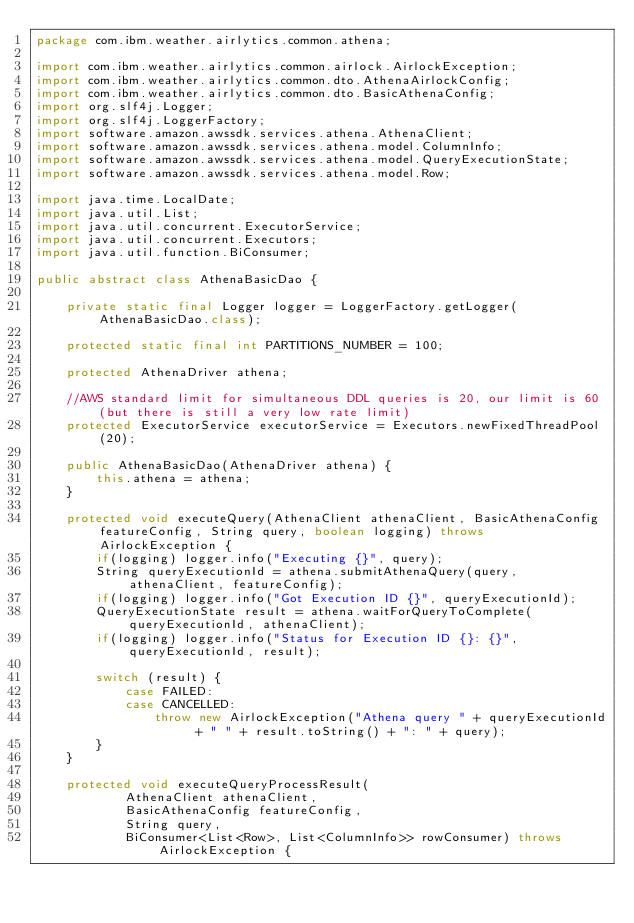<code> <loc_0><loc_0><loc_500><loc_500><_Java_>package com.ibm.weather.airlytics.common.athena;

import com.ibm.weather.airlytics.common.airlock.AirlockException;
import com.ibm.weather.airlytics.common.dto.AthenaAirlockConfig;
import com.ibm.weather.airlytics.common.dto.BasicAthenaConfig;
import org.slf4j.Logger;
import org.slf4j.LoggerFactory;
import software.amazon.awssdk.services.athena.AthenaClient;
import software.amazon.awssdk.services.athena.model.ColumnInfo;
import software.amazon.awssdk.services.athena.model.QueryExecutionState;
import software.amazon.awssdk.services.athena.model.Row;

import java.time.LocalDate;
import java.util.List;
import java.util.concurrent.ExecutorService;
import java.util.concurrent.Executors;
import java.util.function.BiConsumer;

public abstract class AthenaBasicDao {

    private static final Logger logger = LoggerFactory.getLogger(AthenaBasicDao.class);

    protected static final int PARTITIONS_NUMBER = 100;

    protected AthenaDriver athena;

    //AWS standard limit for simultaneous DDL queries is 20, our limit is 60 (but there is still a very low rate limit)
    protected ExecutorService executorService = Executors.newFixedThreadPool(20);

    public AthenaBasicDao(AthenaDriver athena) {
        this.athena = athena;
    }

    protected void executeQuery(AthenaClient athenaClient, BasicAthenaConfig featureConfig, String query, boolean logging) throws AirlockException {
        if(logging) logger.info("Executing {}", query);
        String queryExecutionId = athena.submitAthenaQuery(query, athenaClient, featureConfig);
        if(logging) logger.info("Got Execution ID {}", queryExecutionId);
        QueryExecutionState result = athena.waitForQueryToComplete(queryExecutionId, athenaClient);
        if(logging) logger.info("Status for Execution ID {}: {}", queryExecutionId, result);

        switch (result) {
            case FAILED:
            case CANCELLED:
                throw new AirlockException("Athena query " + queryExecutionId + " " + result.toString() + ": " + query);
        }
    }

    protected void executeQueryProcessResult(
            AthenaClient athenaClient,
            BasicAthenaConfig featureConfig,
            String query,
            BiConsumer<List<Row>, List<ColumnInfo>> rowConsumer) throws AirlockException {</code> 